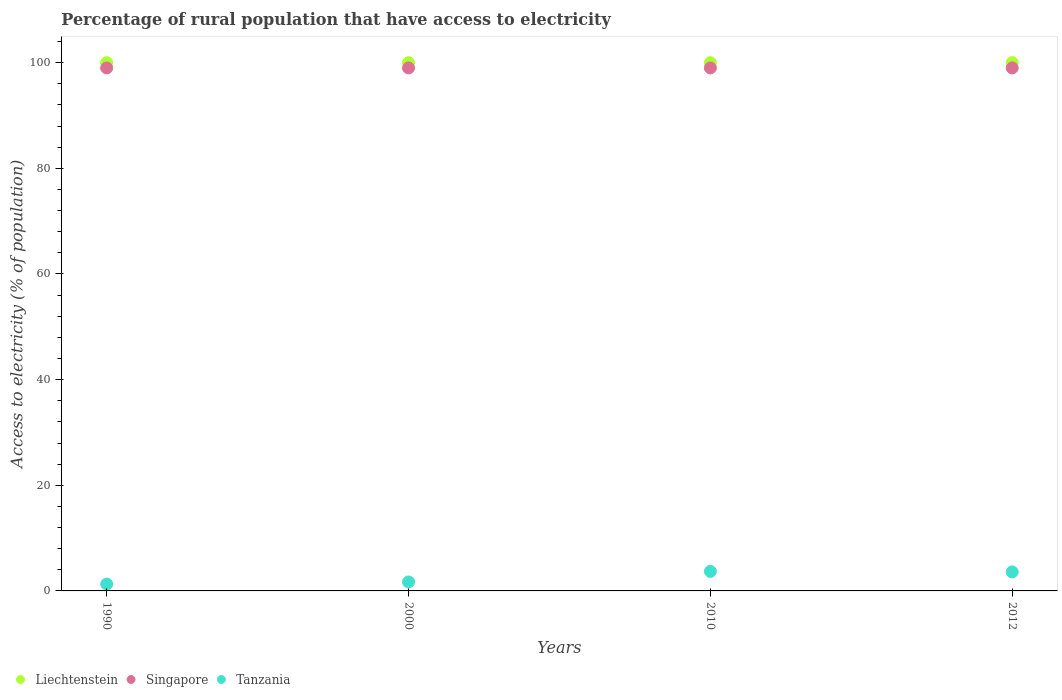How many different coloured dotlines are there?
Provide a succinct answer. 3. Is the number of dotlines equal to the number of legend labels?
Your response must be concise. Yes. What is the percentage of rural population that have access to electricity in Singapore in 2010?
Provide a short and direct response. 99. Across all years, what is the maximum percentage of rural population that have access to electricity in Liechtenstein?
Make the answer very short. 100. Across all years, what is the minimum percentage of rural population that have access to electricity in Singapore?
Offer a very short reply. 99. What is the total percentage of rural population that have access to electricity in Liechtenstein in the graph?
Provide a succinct answer. 400. What is the difference between the percentage of rural population that have access to electricity in Singapore in 1990 and that in 2000?
Keep it short and to the point. 0. What is the difference between the percentage of rural population that have access to electricity in Tanzania in 1990 and the percentage of rural population that have access to electricity in Liechtenstein in 2012?
Provide a short and direct response. -98.7. What is the average percentage of rural population that have access to electricity in Tanzania per year?
Your response must be concise. 2.58. In the year 2000, what is the difference between the percentage of rural population that have access to electricity in Singapore and percentage of rural population that have access to electricity in Tanzania?
Make the answer very short. 97.3. Is the difference between the percentage of rural population that have access to electricity in Singapore in 1990 and 2010 greater than the difference between the percentage of rural population that have access to electricity in Tanzania in 1990 and 2010?
Give a very brief answer. Yes. What is the difference between the highest and the second highest percentage of rural population that have access to electricity in Liechtenstein?
Provide a succinct answer. 0. What is the difference between the highest and the lowest percentage of rural population that have access to electricity in Singapore?
Make the answer very short. 0. In how many years, is the percentage of rural population that have access to electricity in Singapore greater than the average percentage of rural population that have access to electricity in Singapore taken over all years?
Provide a short and direct response. 0. Is it the case that in every year, the sum of the percentage of rural population that have access to electricity in Liechtenstein and percentage of rural population that have access to electricity in Tanzania  is greater than the percentage of rural population that have access to electricity in Singapore?
Ensure brevity in your answer.  Yes. Is the percentage of rural population that have access to electricity in Liechtenstein strictly greater than the percentage of rural population that have access to electricity in Singapore over the years?
Your response must be concise. Yes. Is the percentage of rural population that have access to electricity in Liechtenstein strictly less than the percentage of rural population that have access to electricity in Singapore over the years?
Offer a very short reply. No. How many dotlines are there?
Provide a succinct answer. 3. Does the graph contain any zero values?
Keep it short and to the point. No. Does the graph contain grids?
Provide a succinct answer. No. Where does the legend appear in the graph?
Provide a succinct answer. Bottom left. How are the legend labels stacked?
Your response must be concise. Horizontal. What is the title of the graph?
Make the answer very short. Percentage of rural population that have access to electricity. Does "Sierra Leone" appear as one of the legend labels in the graph?
Ensure brevity in your answer.  No. What is the label or title of the X-axis?
Offer a very short reply. Years. What is the label or title of the Y-axis?
Offer a terse response. Access to electricity (% of population). What is the Access to electricity (% of population) of Liechtenstein in 1990?
Offer a terse response. 100. What is the Access to electricity (% of population) of Singapore in 1990?
Keep it short and to the point. 99. What is the Access to electricity (% of population) in Tanzania in 1990?
Offer a terse response. 1.3. What is the Access to electricity (% of population) in Liechtenstein in 2000?
Give a very brief answer. 100. What is the Access to electricity (% of population) in Singapore in 2000?
Keep it short and to the point. 99. What is the Access to electricity (% of population) in Liechtenstein in 2010?
Your answer should be very brief. 100. What is the Access to electricity (% of population) of Singapore in 2010?
Keep it short and to the point. 99. What is the Access to electricity (% of population) in Liechtenstein in 2012?
Offer a terse response. 100. Across all years, what is the minimum Access to electricity (% of population) of Liechtenstein?
Provide a succinct answer. 100. Across all years, what is the minimum Access to electricity (% of population) of Tanzania?
Offer a very short reply. 1.3. What is the total Access to electricity (% of population) in Liechtenstein in the graph?
Make the answer very short. 400. What is the total Access to electricity (% of population) of Singapore in the graph?
Your answer should be very brief. 396. What is the total Access to electricity (% of population) of Tanzania in the graph?
Provide a succinct answer. 10.3. What is the difference between the Access to electricity (% of population) in Liechtenstein in 1990 and that in 2010?
Your response must be concise. 0. What is the difference between the Access to electricity (% of population) of Singapore in 1990 and that in 2012?
Your answer should be very brief. 0. What is the difference between the Access to electricity (% of population) of Tanzania in 1990 and that in 2012?
Your answer should be compact. -2.3. What is the difference between the Access to electricity (% of population) in Liechtenstein in 2000 and that in 2010?
Provide a succinct answer. 0. What is the difference between the Access to electricity (% of population) of Singapore in 2000 and that in 2010?
Offer a very short reply. 0. What is the difference between the Access to electricity (% of population) of Liechtenstein in 2000 and that in 2012?
Your response must be concise. 0. What is the difference between the Access to electricity (% of population) in Singapore in 2000 and that in 2012?
Keep it short and to the point. 0. What is the difference between the Access to electricity (% of population) of Tanzania in 2000 and that in 2012?
Provide a succinct answer. -1.9. What is the difference between the Access to electricity (% of population) in Liechtenstein in 2010 and that in 2012?
Offer a very short reply. 0. What is the difference between the Access to electricity (% of population) in Singapore in 2010 and that in 2012?
Provide a short and direct response. 0. What is the difference between the Access to electricity (% of population) in Tanzania in 2010 and that in 2012?
Provide a short and direct response. 0.1. What is the difference between the Access to electricity (% of population) of Liechtenstein in 1990 and the Access to electricity (% of population) of Singapore in 2000?
Ensure brevity in your answer.  1. What is the difference between the Access to electricity (% of population) of Liechtenstein in 1990 and the Access to electricity (% of population) of Tanzania in 2000?
Provide a succinct answer. 98.3. What is the difference between the Access to electricity (% of population) in Singapore in 1990 and the Access to electricity (% of population) in Tanzania in 2000?
Your answer should be very brief. 97.3. What is the difference between the Access to electricity (% of population) of Liechtenstein in 1990 and the Access to electricity (% of population) of Singapore in 2010?
Provide a succinct answer. 1. What is the difference between the Access to electricity (% of population) of Liechtenstein in 1990 and the Access to electricity (% of population) of Tanzania in 2010?
Keep it short and to the point. 96.3. What is the difference between the Access to electricity (% of population) of Singapore in 1990 and the Access to electricity (% of population) of Tanzania in 2010?
Ensure brevity in your answer.  95.3. What is the difference between the Access to electricity (% of population) of Liechtenstein in 1990 and the Access to electricity (% of population) of Singapore in 2012?
Your response must be concise. 1. What is the difference between the Access to electricity (% of population) in Liechtenstein in 1990 and the Access to electricity (% of population) in Tanzania in 2012?
Your response must be concise. 96.4. What is the difference between the Access to electricity (% of population) of Singapore in 1990 and the Access to electricity (% of population) of Tanzania in 2012?
Ensure brevity in your answer.  95.4. What is the difference between the Access to electricity (% of population) of Liechtenstein in 2000 and the Access to electricity (% of population) of Tanzania in 2010?
Keep it short and to the point. 96.3. What is the difference between the Access to electricity (% of population) in Singapore in 2000 and the Access to electricity (% of population) in Tanzania in 2010?
Provide a short and direct response. 95.3. What is the difference between the Access to electricity (% of population) in Liechtenstein in 2000 and the Access to electricity (% of population) in Tanzania in 2012?
Provide a short and direct response. 96.4. What is the difference between the Access to electricity (% of population) of Singapore in 2000 and the Access to electricity (% of population) of Tanzania in 2012?
Keep it short and to the point. 95.4. What is the difference between the Access to electricity (% of population) of Liechtenstein in 2010 and the Access to electricity (% of population) of Tanzania in 2012?
Make the answer very short. 96.4. What is the difference between the Access to electricity (% of population) of Singapore in 2010 and the Access to electricity (% of population) of Tanzania in 2012?
Offer a terse response. 95.4. What is the average Access to electricity (% of population) of Liechtenstein per year?
Offer a very short reply. 100. What is the average Access to electricity (% of population) in Tanzania per year?
Provide a short and direct response. 2.58. In the year 1990, what is the difference between the Access to electricity (% of population) in Liechtenstein and Access to electricity (% of population) in Singapore?
Your answer should be very brief. 1. In the year 1990, what is the difference between the Access to electricity (% of population) of Liechtenstein and Access to electricity (% of population) of Tanzania?
Make the answer very short. 98.7. In the year 1990, what is the difference between the Access to electricity (% of population) of Singapore and Access to electricity (% of population) of Tanzania?
Ensure brevity in your answer.  97.7. In the year 2000, what is the difference between the Access to electricity (% of population) in Liechtenstein and Access to electricity (% of population) in Tanzania?
Provide a succinct answer. 98.3. In the year 2000, what is the difference between the Access to electricity (% of population) of Singapore and Access to electricity (% of population) of Tanzania?
Provide a succinct answer. 97.3. In the year 2010, what is the difference between the Access to electricity (% of population) of Liechtenstein and Access to electricity (% of population) of Singapore?
Your answer should be very brief. 1. In the year 2010, what is the difference between the Access to electricity (% of population) of Liechtenstein and Access to electricity (% of population) of Tanzania?
Your answer should be compact. 96.3. In the year 2010, what is the difference between the Access to electricity (% of population) in Singapore and Access to electricity (% of population) in Tanzania?
Give a very brief answer. 95.3. In the year 2012, what is the difference between the Access to electricity (% of population) in Liechtenstein and Access to electricity (% of population) in Tanzania?
Make the answer very short. 96.4. In the year 2012, what is the difference between the Access to electricity (% of population) in Singapore and Access to electricity (% of population) in Tanzania?
Your answer should be compact. 95.4. What is the ratio of the Access to electricity (% of population) in Singapore in 1990 to that in 2000?
Your answer should be compact. 1. What is the ratio of the Access to electricity (% of population) of Tanzania in 1990 to that in 2000?
Your response must be concise. 0.76. What is the ratio of the Access to electricity (% of population) of Liechtenstein in 1990 to that in 2010?
Offer a very short reply. 1. What is the ratio of the Access to electricity (% of population) of Tanzania in 1990 to that in 2010?
Make the answer very short. 0.35. What is the ratio of the Access to electricity (% of population) of Liechtenstein in 1990 to that in 2012?
Provide a succinct answer. 1. What is the ratio of the Access to electricity (% of population) of Singapore in 1990 to that in 2012?
Offer a terse response. 1. What is the ratio of the Access to electricity (% of population) in Tanzania in 1990 to that in 2012?
Provide a short and direct response. 0.36. What is the ratio of the Access to electricity (% of population) of Liechtenstein in 2000 to that in 2010?
Make the answer very short. 1. What is the ratio of the Access to electricity (% of population) in Tanzania in 2000 to that in 2010?
Give a very brief answer. 0.46. What is the ratio of the Access to electricity (% of population) in Liechtenstein in 2000 to that in 2012?
Provide a short and direct response. 1. What is the ratio of the Access to electricity (% of population) in Tanzania in 2000 to that in 2012?
Your response must be concise. 0.47. What is the ratio of the Access to electricity (% of population) in Liechtenstein in 2010 to that in 2012?
Provide a short and direct response. 1. What is the ratio of the Access to electricity (% of population) in Singapore in 2010 to that in 2012?
Keep it short and to the point. 1. What is the ratio of the Access to electricity (% of population) in Tanzania in 2010 to that in 2012?
Make the answer very short. 1.03. What is the difference between the highest and the second highest Access to electricity (% of population) of Tanzania?
Keep it short and to the point. 0.1. What is the difference between the highest and the lowest Access to electricity (% of population) in Singapore?
Your answer should be compact. 0. 